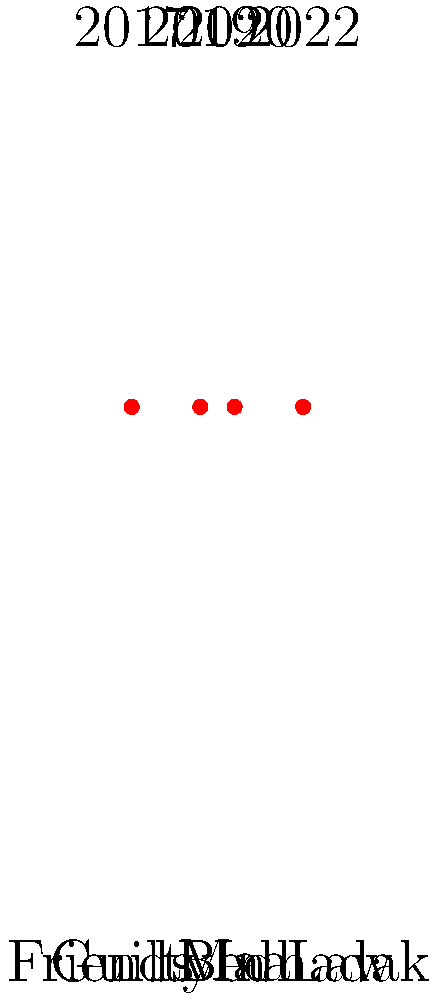Based on the timeline of Gurfateh Pirzada's filmography shown above, which movie marked his debut in Bollywood and in which year was it released? To answer this question, we need to analyze the timeline of Gurfateh Pirzada's filmography:

1. The timeline shows four movies: "Guilty", "Friends In Law", "Maa", and "Bedhadak".
2. The years associated with these movies are 2020, 2019, 2017, and 2022 respectively.
3. To determine his debut film, we need to identify the earliest year on the timeline.
4. The earliest year shown is 2017.
5. The movie associated with 2017 is "Maa".

Therefore, "Maa" marked Gurfateh Pirzada's debut in Bollywood, and it was released in 2017.
Answer: Maa (2017) 